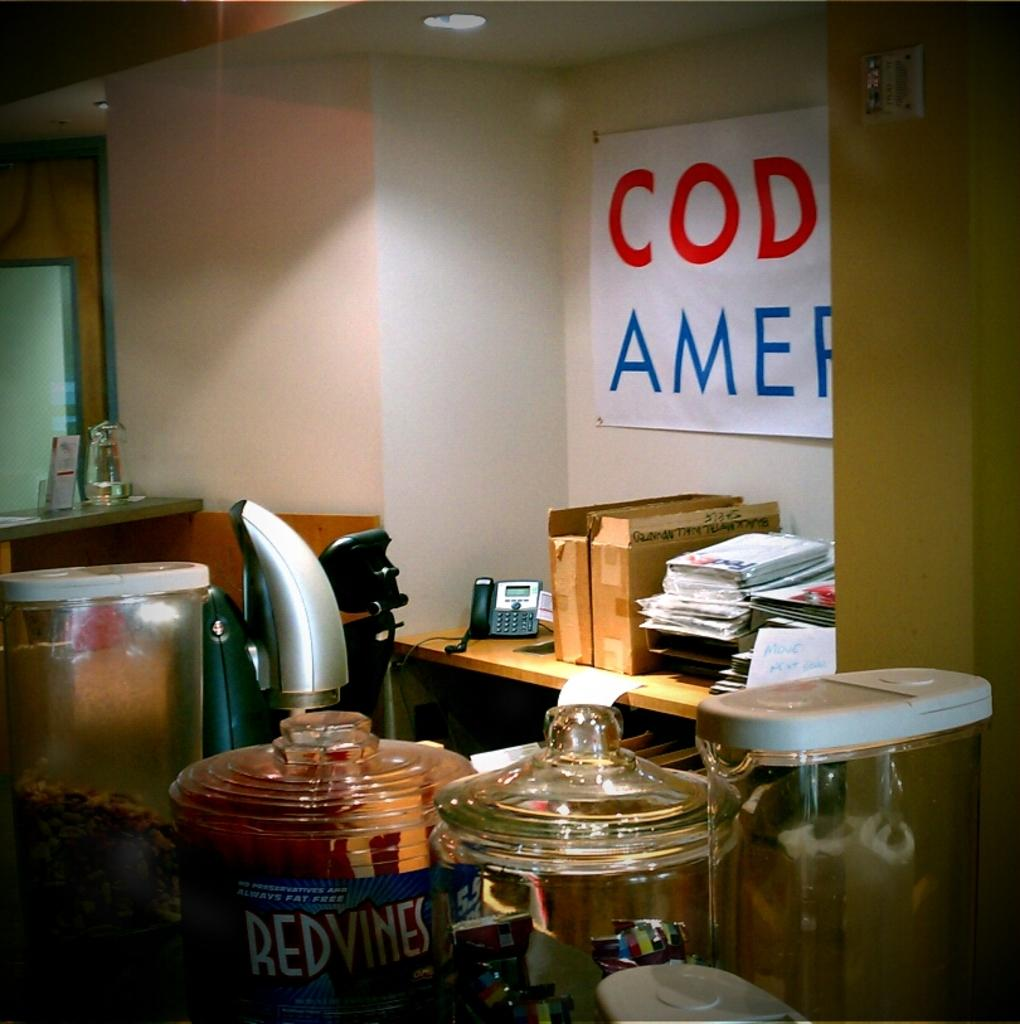<image>
Provide a brief description of the given image. A office with a banner maybe saying something about America 